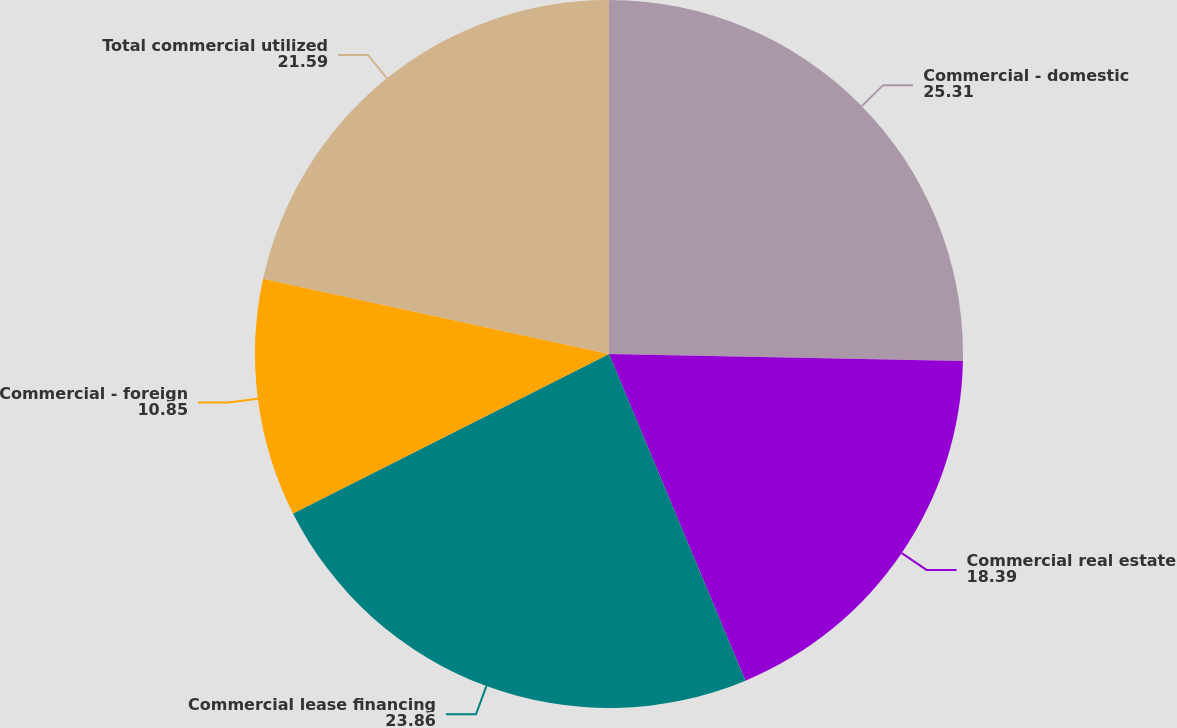<chart> <loc_0><loc_0><loc_500><loc_500><pie_chart><fcel>Commercial - domestic<fcel>Commercial real estate<fcel>Commercial lease financing<fcel>Commercial - foreign<fcel>Total commercial utilized<nl><fcel>25.31%<fcel>18.39%<fcel>23.86%<fcel>10.85%<fcel>21.59%<nl></chart> 